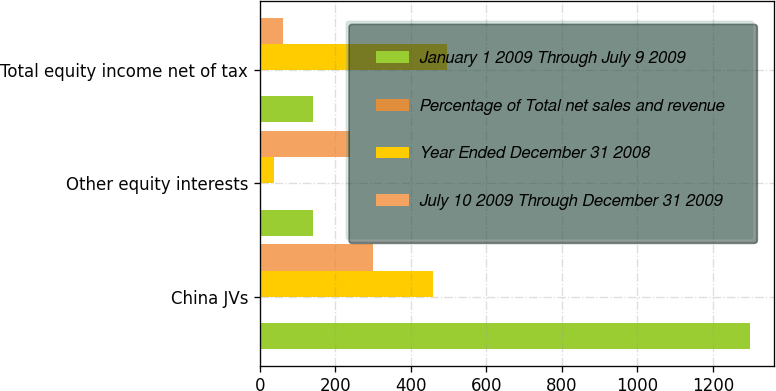<chart> <loc_0><loc_0><loc_500><loc_500><stacked_bar_chart><ecel><fcel>China JVs<fcel>Other equity interests<fcel>Total equity income net of tax<nl><fcel>January 1 2009 Through July 9 2009<fcel>1297<fcel>141<fcel>141<nl><fcel>Percentage of Total net sales and revenue<fcel>1<fcel>0.1<fcel>1.1<nl><fcel>Year Ended December 31 2008<fcel>460<fcel>37<fcel>497<nl><fcel>July 10 2009 Through December 31 2009<fcel>300<fcel>239<fcel>61<nl></chart> 